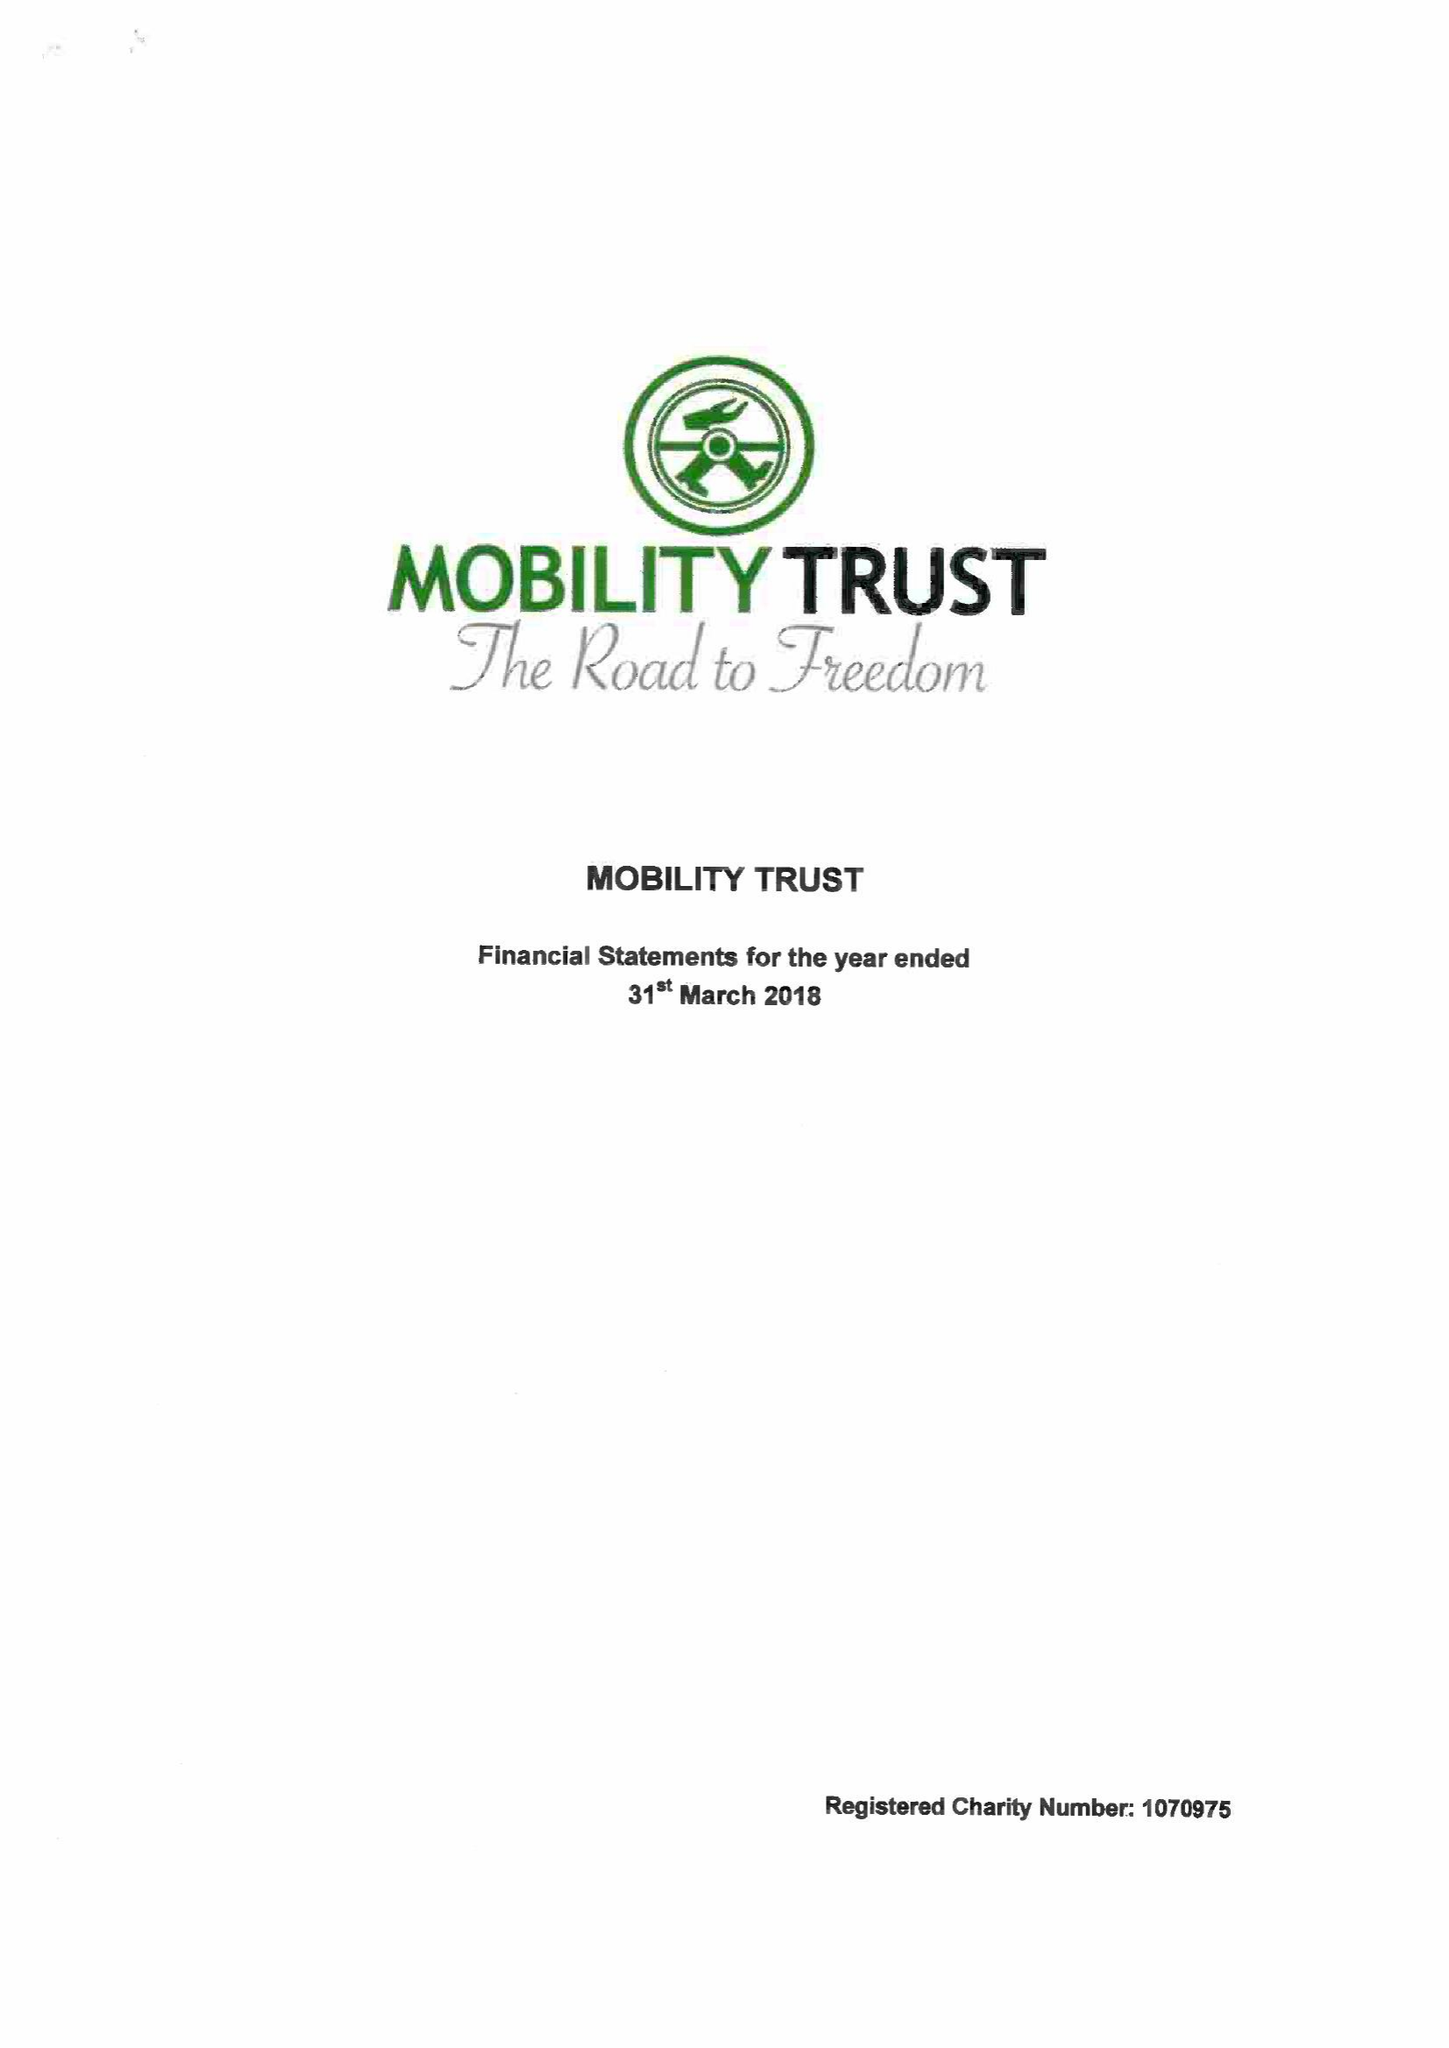What is the value for the spending_annually_in_british_pounds?
Answer the question using a single word or phrase. 396798.00 